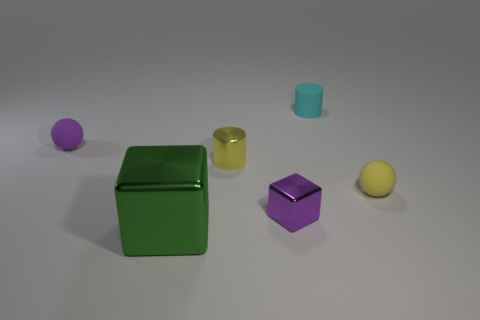Add 1 gray rubber blocks. How many objects exist? 7 Subtract all balls. How many objects are left? 4 Add 1 small cylinders. How many small cylinders are left? 3 Add 5 tiny yellow things. How many tiny yellow things exist? 7 Subtract 0 cyan cubes. How many objects are left? 6 Subtract all rubber balls. Subtract all green objects. How many objects are left? 3 